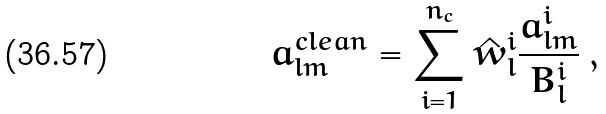Convert formula to latex. <formula><loc_0><loc_0><loc_500><loc_500>a _ { l m } ^ { c l e a n } = \sum _ { i = 1 } ^ { n _ { c } } \hat { w } _ { l } ^ { i } \frac { a _ { l m } ^ { i } } { B _ { l } ^ { i } } \, ,</formula> 